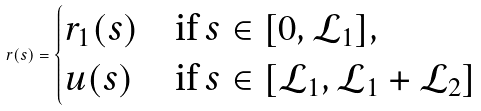<formula> <loc_0><loc_0><loc_500><loc_500>r ( s ) = \begin{cases} r _ { 1 } ( s ) & \text {if $s\in [0,\mathcal{L}_{1}]$} , \\ u ( s ) & \text {if $s\in  [\mathcal{L}_{1}, \mathcal{L}_{1}+\mathcal{L}_{2}]$} \end{cases}</formula> 